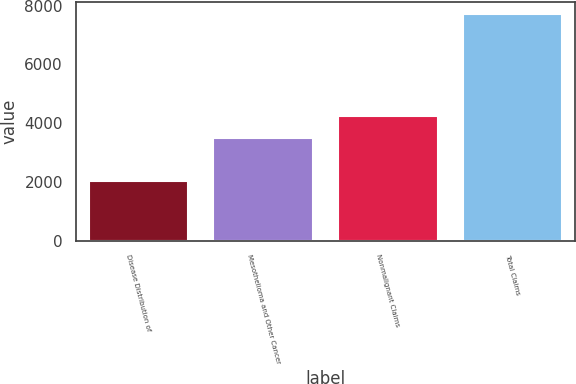Convert chart. <chart><loc_0><loc_0><loc_500><loc_500><bar_chart><fcel>Disease Distribution of<fcel>Mesothelioma and Other Cancer<fcel>Nonmalignant Claims<fcel>Total Claims<nl><fcel>2016<fcel>3490<fcel>4234<fcel>7724<nl></chart> 